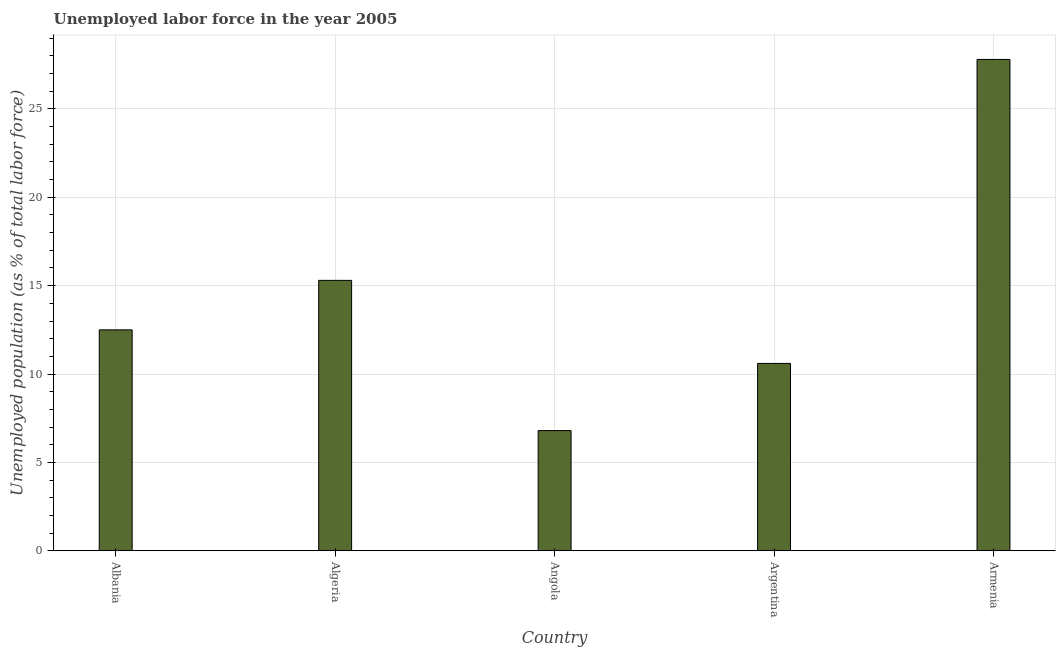Does the graph contain grids?
Your response must be concise. Yes. What is the title of the graph?
Provide a succinct answer. Unemployed labor force in the year 2005. What is the label or title of the X-axis?
Your answer should be compact. Country. What is the label or title of the Y-axis?
Offer a very short reply. Unemployed population (as % of total labor force). What is the total unemployed population in Armenia?
Your answer should be very brief. 27.8. Across all countries, what is the maximum total unemployed population?
Your response must be concise. 27.8. Across all countries, what is the minimum total unemployed population?
Make the answer very short. 6.8. In which country was the total unemployed population maximum?
Provide a short and direct response. Armenia. In which country was the total unemployed population minimum?
Ensure brevity in your answer.  Angola. What is the sum of the total unemployed population?
Offer a very short reply. 73. What is the difference between the total unemployed population in Albania and Algeria?
Offer a very short reply. -2.8. What is the median total unemployed population?
Provide a succinct answer. 12.5. What is the ratio of the total unemployed population in Algeria to that in Angola?
Offer a terse response. 2.25. What is the difference between the highest and the second highest total unemployed population?
Provide a succinct answer. 12.5. In how many countries, is the total unemployed population greater than the average total unemployed population taken over all countries?
Your response must be concise. 2. How many bars are there?
Your answer should be compact. 5. What is the Unemployed population (as % of total labor force) in Albania?
Provide a succinct answer. 12.5. What is the Unemployed population (as % of total labor force) of Algeria?
Offer a terse response. 15.3. What is the Unemployed population (as % of total labor force) of Angola?
Offer a very short reply. 6.8. What is the Unemployed population (as % of total labor force) of Argentina?
Give a very brief answer. 10.6. What is the Unemployed population (as % of total labor force) of Armenia?
Provide a short and direct response. 27.8. What is the difference between the Unemployed population (as % of total labor force) in Albania and Algeria?
Your response must be concise. -2.8. What is the difference between the Unemployed population (as % of total labor force) in Albania and Argentina?
Your response must be concise. 1.9. What is the difference between the Unemployed population (as % of total labor force) in Albania and Armenia?
Give a very brief answer. -15.3. What is the difference between the Unemployed population (as % of total labor force) in Algeria and Argentina?
Your response must be concise. 4.7. What is the difference between the Unemployed population (as % of total labor force) in Algeria and Armenia?
Your answer should be compact. -12.5. What is the difference between the Unemployed population (as % of total labor force) in Angola and Armenia?
Ensure brevity in your answer.  -21. What is the difference between the Unemployed population (as % of total labor force) in Argentina and Armenia?
Provide a short and direct response. -17.2. What is the ratio of the Unemployed population (as % of total labor force) in Albania to that in Algeria?
Offer a terse response. 0.82. What is the ratio of the Unemployed population (as % of total labor force) in Albania to that in Angola?
Provide a short and direct response. 1.84. What is the ratio of the Unemployed population (as % of total labor force) in Albania to that in Argentina?
Make the answer very short. 1.18. What is the ratio of the Unemployed population (as % of total labor force) in Albania to that in Armenia?
Provide a succinct answer. 0.45. What is the ratio of the Unemployed population (as % of total labor force) in Algeria to that in Angola?
Your response must be concise. 2.25. What is the ratio of the Unemployed population (as % of total labor force) in Algeria to that in Argentina?
Your answer should be compact. 1.44. What is the ratio of the Unemployed population (as % of total labor force) in Algeria to that in Armenia?
Make the answer very short. 0.55. What is the ratio of the Unemployed population (as % of total labor force) in Angola to that in Argentina?
Keep it short and to the point. 0.64. What is the ratio of the Unemployed population (as % of total labor force) in Angola to that in Armenia?
Your answer should be compact. 0.24. What is the ratio of the Unemployed population (as % of total labor force) in Argentina to that in Armenia?
Provide a succinct answer. 0.38. 